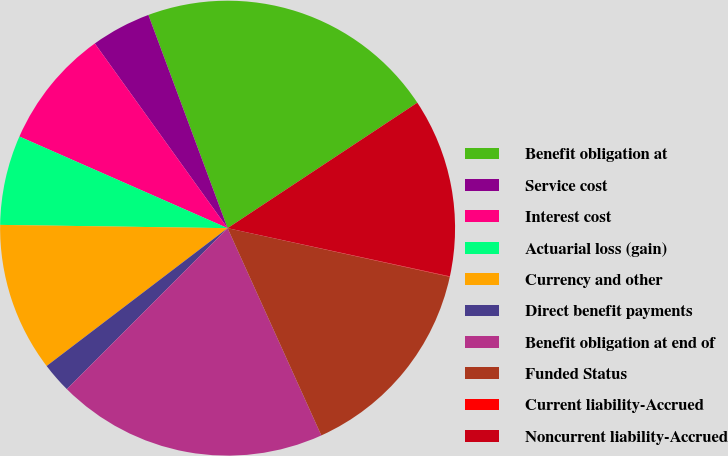<chart> <loc_0><loc_0><loc_500><loc_500><pie_chart><fcel>Benefit obligation at<fcel>Service cost<fcel>Interest cost<fcel>Actuarial loss (gain)<fcel>Currency and other<fcel>Direct benefit payments<fcel>Benefit obligation at end of<fcel>Funded Status<fcel>Current liability-Accrued<fcel>Noncurrent liability-Accrued<nl><fcel>21.36%<fcel>4.26%<fcel>8.48%<fcel>6.37%<fcel>10.59%<fcel>2.15%<fcel>19.25%<fcel>14.81%<fcel>0.03%<fcel>12.7%<nl></chart> 